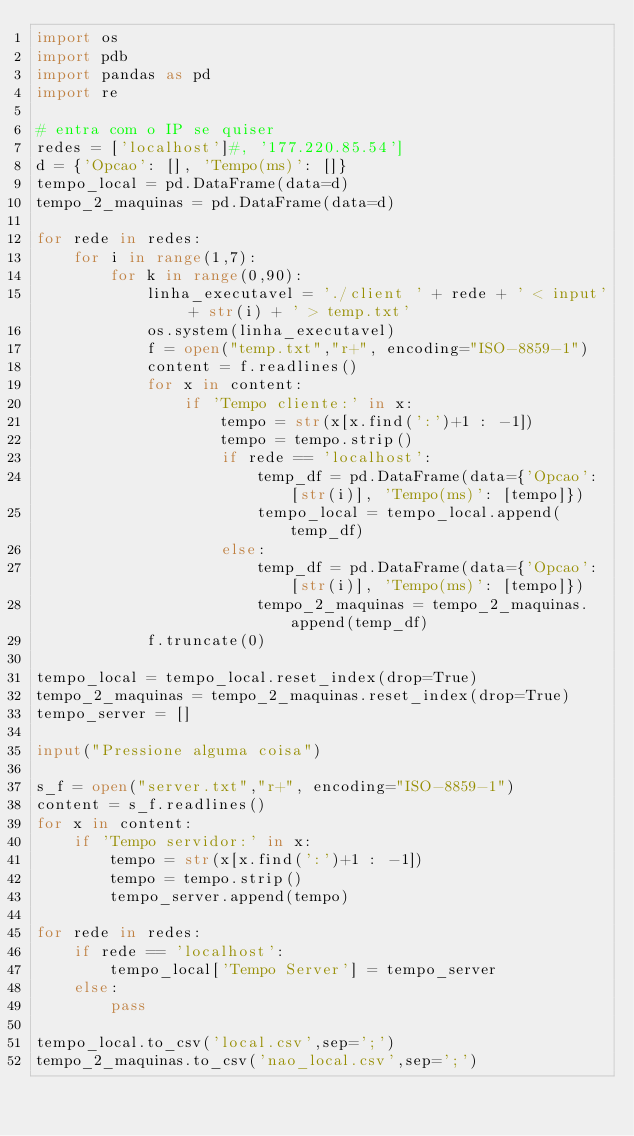Convert code to text. <code><loc_0><loc_0><loc_500><loc_500><_Python_>import os
import pdb
import pandas as pd
import re

# entra com o IP se quiser
redes = ['localhost']#, '177.220.85.54']
d = {'Opcao': [], 'Tempo(ms)': []}
tempo_local = pd.DataFrame(data=d)
tempo_2_maquinas = pd.DataFrame(data=d)

for rede in redes:
    for i in range(1,7):
        for k in range(0,90):
            linha_executavel = './client ' + rede + ' < input' + str(i) + ' > temp.txt'
            os.system(linha_executavel)
            f = open("temp.txt","r+", encoding="ISO-8859-1")
            content = f.readlines()
            for x in content:
                if 'Tempo cliente:' in x:
                    tempo = str(x[x.find(':')+1 : -1])
                    tempo = tempo.strip()
                    if rede == 'localhost':
                        temp_df = pd.DataFrame(data={'Opcao': [str(i)], 'Tempo(ms)': [tempo]})
                        tempo_local = tempo_local.append(temp_df)
                    else:
                        temp_df = pd.DataFrame(data={'Opcao': [str(i)], 'Tempo(ms)': [tempo]})
                        tempo_2_maquinas = tempo_2_maquinas.append(temp_df)
            f.truncate(0)

tempo_local = tempo_local.reset_index(drop=True)
tempo_2_maquinas = tempo_2_maquinas.reset_index(drop=True)
tempo_server = []

input("Pressione alguma coisa")

s_f = open("server.txt","r+", encoding="ISO-8859-1")
content = s_f.readlines()
for x in content:
    if 'Tempo servidor:' in x:
        tempo = str(x[x.find(':')+1 : -1])
        tempo = tempo.strip()
        tempo_server.append(tempo)

for rede in redes:
    if rede == 'localhost':
        tempo_local['Tempo Server'] = tempo_server
    else:
        pass

tempo_local.to_csv('local.csv',sep=';')
tempo_2_maquinas.to_csv('nao_local.csv',sep=';')
</code> 